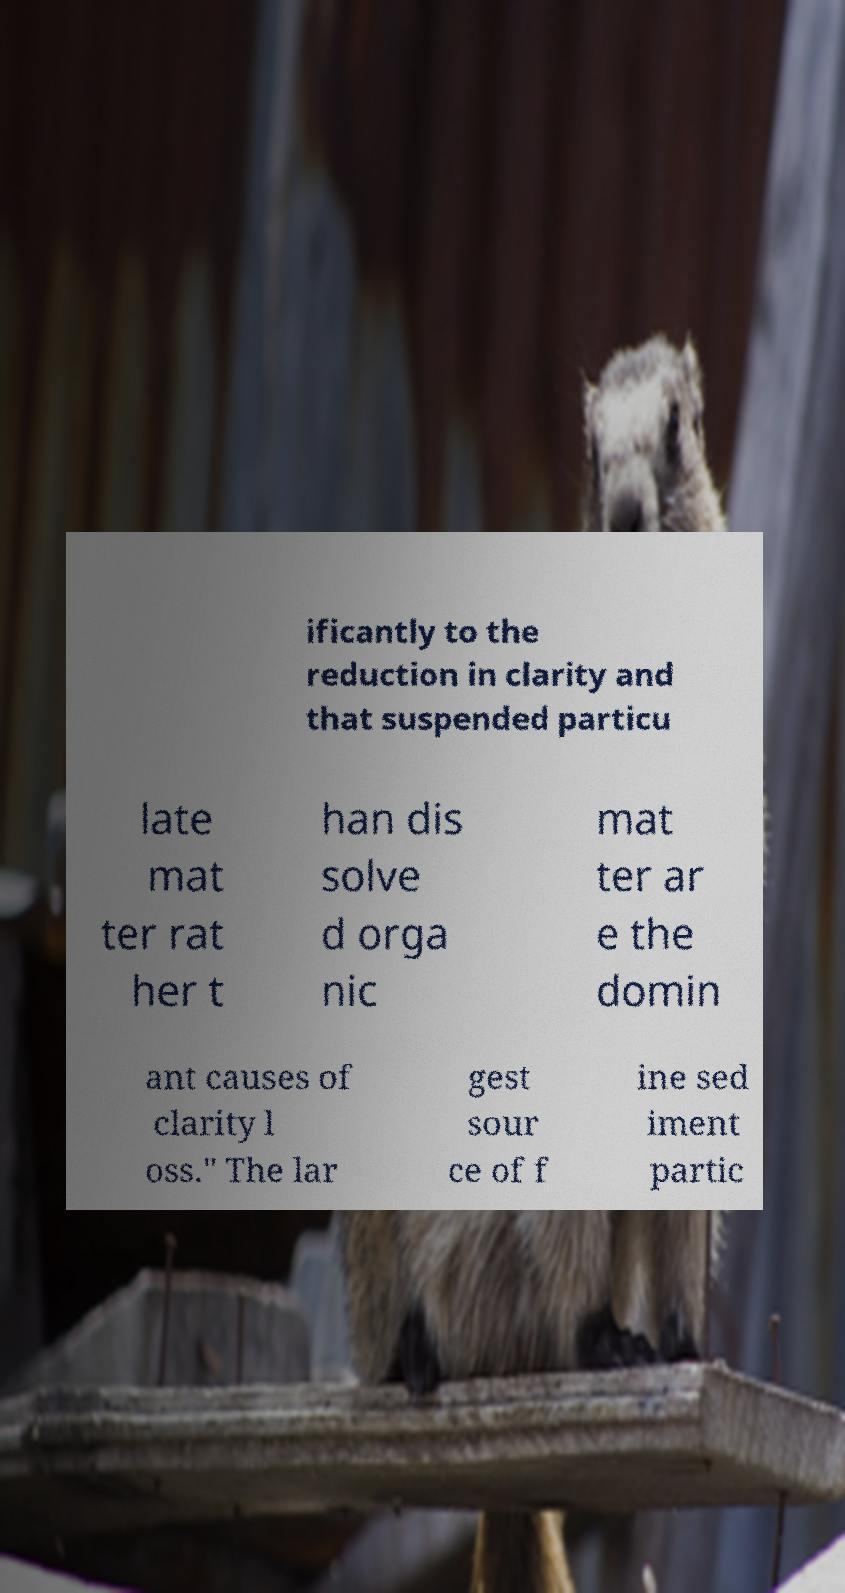Please identify and transcribe the text found in this image. ificantly to the reduction in clarity and that suspended particu late mat ter rat her t han dis solve d orga nic mat ter ar e the domin ant causes of clarity l oss." The lar gest sour ce of f ine sed iment partic 